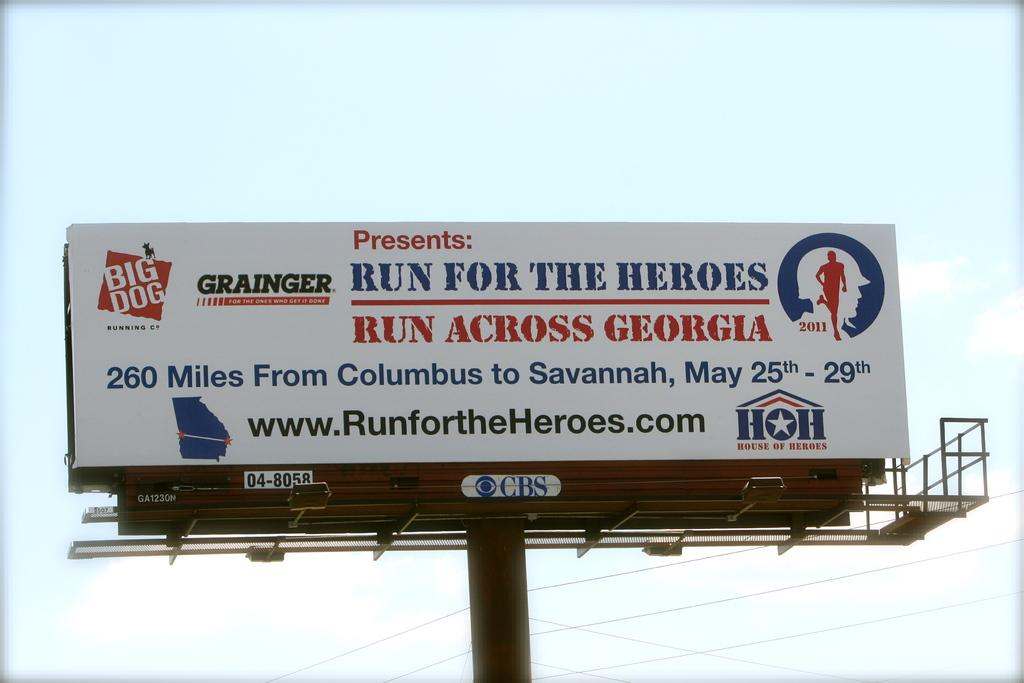Provide a one-sentence caption for the provided image. A billboard advertises the Run for the Heroes/Run Across Georgia event. 